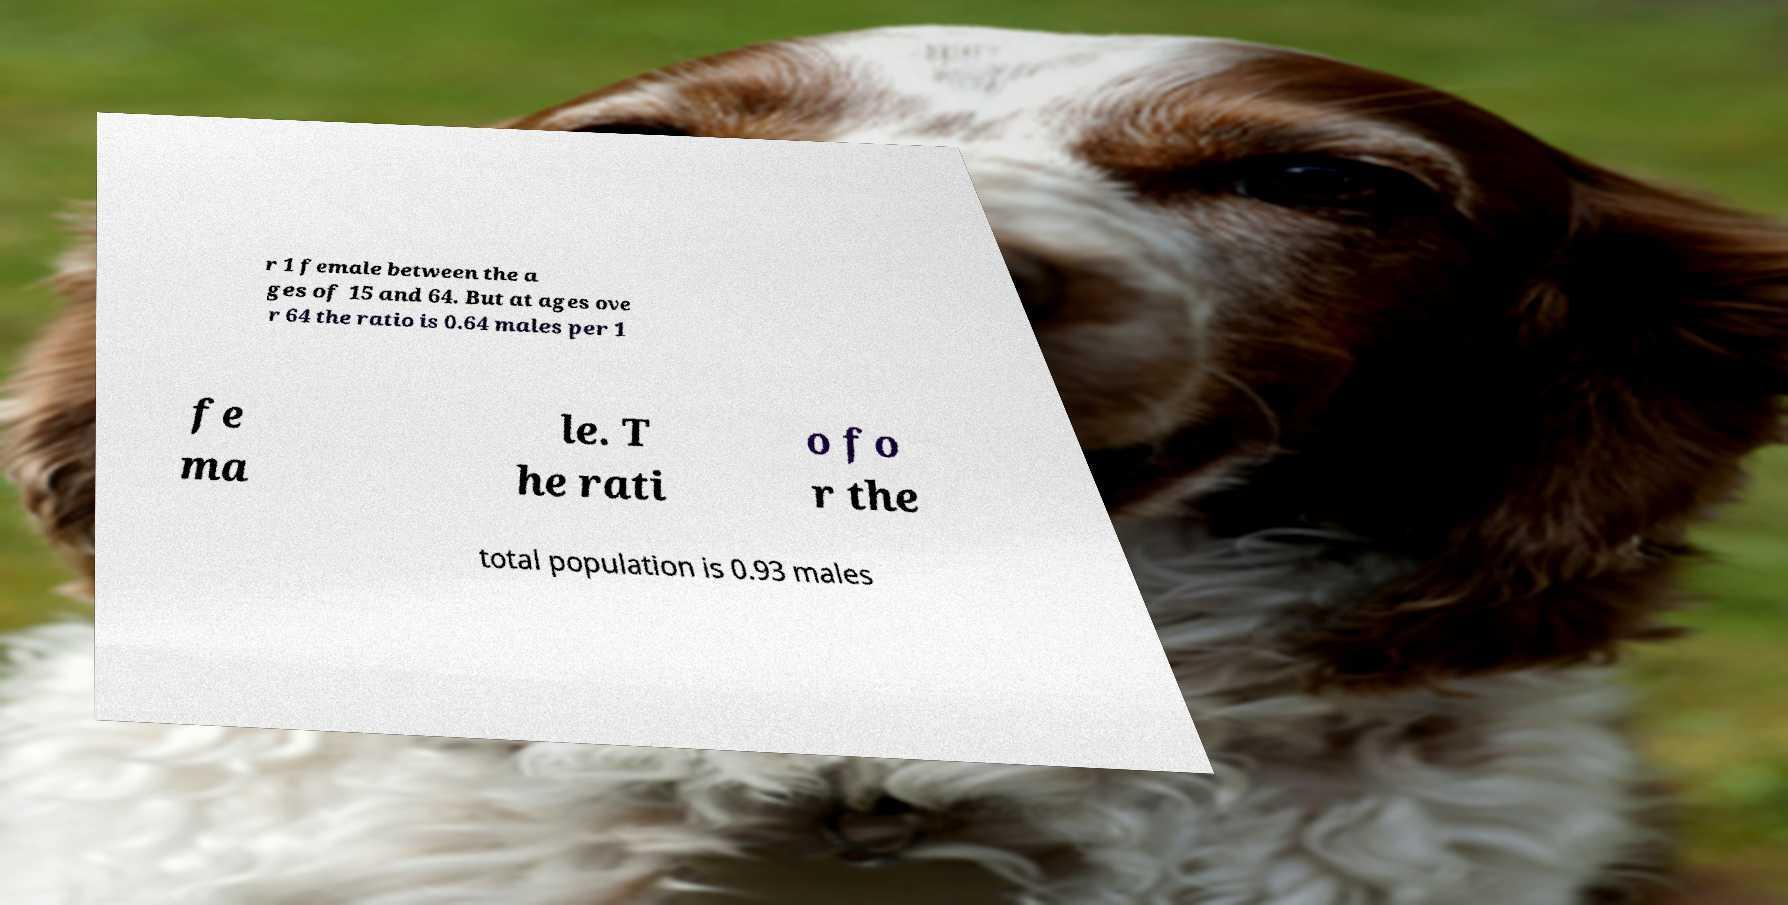Can you accurately transcribe the text from the provided image for me? r 1 female between the a ges of 15 and 64. But at ages ove r 64 the ratio is 0.64 males per 1 fe ma le. T he rati o fo r the total population is 0.93 males 